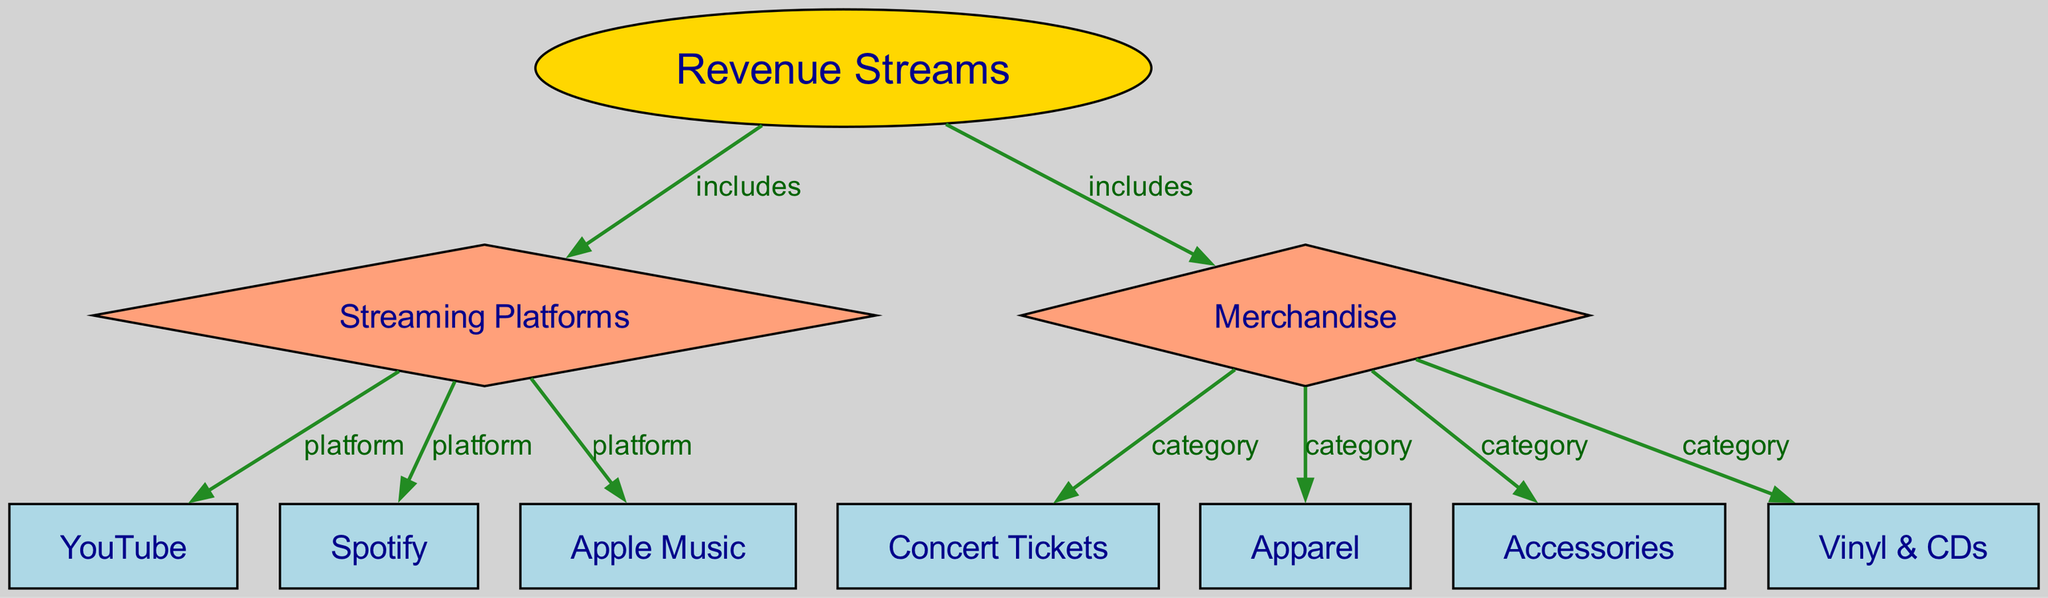What category does the 'Revenue Streams' node include? The 'Revenue Streams' node is connected to two categories: 'Streaming Platforms' and 'Merchandise' which are indicated in the edges that come from the 'Revenue Streams' node.
Answer: Streaming Platforms, Merchandise How many streaming platforms are listed? The 'Streaming Platforms' node points to three individual platforms: 'YouTube', 'Spotify', and 'Apple Music', which are directly connected to it, so counting them gives us a total of three.
Answer: 3 What type of node is 'Merchandise'? In the diagram, 'Merchandise' is represented as a diamond-shaped node, indicating its role as a category within the revenue streams.
Answer: diamond Which node is connected to 'Apple Music'? The 'Apple Music' node is directly connected to the 'Streaming Platforms' node via an edge labeled 'platform', indicating its classification as a platform under the streaming category.
Answer: Streaming Platforms What are the merchandise categories included? The 'Merchandise' node connects to four specific categories: 'Concert Tickets', 'Apparel', 'Accessories', and 'Vinyl & CDs', which are indicated by the edges extending from the 'Merchandise' node.
Answer: Concert Tickets, Apparel, Accessories, Vinyl & CDs How many edges are present in the diagram? To determine the total number of edges, we can count each unique connection. There are a total of eight edges listed connecting the nodes logically throughout the diagram.
Answer: 8 Which platform is connected to the node that includes 'YouTube'? The 'YouTube' node, which represents a streaming platform, is directly linked to the 'Streaming Platforms' node, indicating that it is one of the platforms listed under streaming.
Answer: Streaming Platforms What do the edges represent in the diagram? The edges in the diagram represent the relationships between different nodes, illustrating how 'Revenue Streams' encompasses both 'Streaming Platforms' and 'Merchandise', and specifying the categories and types of each.
Answer: relationships 